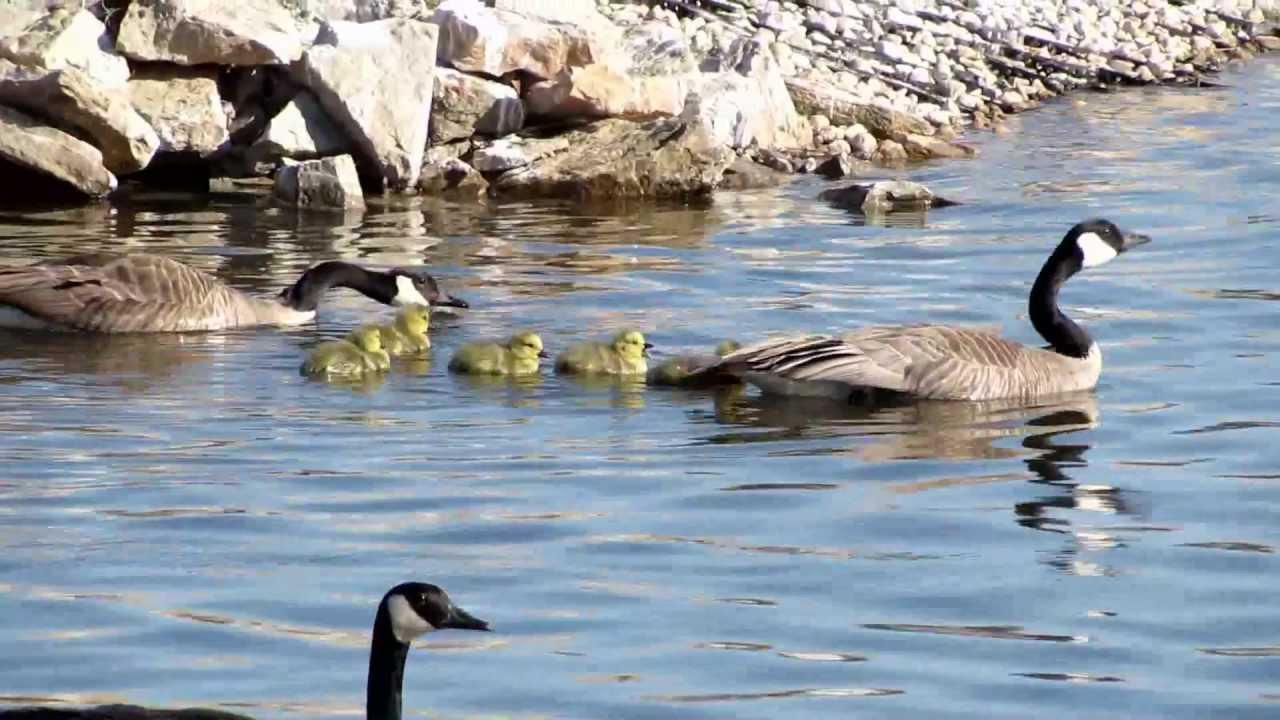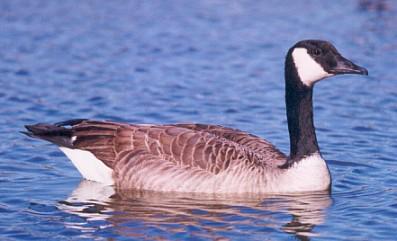The first image is the image on the left, the second image is the image on the right. For the images displayed, is the sentence "There are two adult Canadian geese floating on water" factually correct? Answer yes or no. No. The first image is the image on the left, the second image is the image on the right. Assess this claim about the two images: "The image on the right has no more than one duck and it's body is facing right.". Correct or not? Answer yes or no. Yes. 